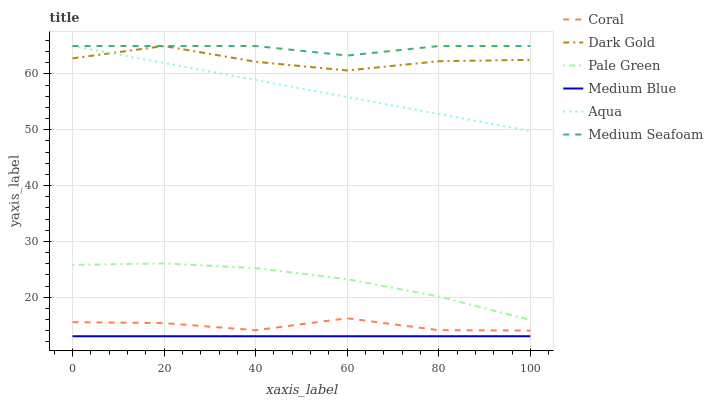Does Medium Blue have the minimum area under the curve?
Answer yes or no. Yes. Does Medium Seafoam have the maximum area under the curve?
Answer yes or no. Yes. Does Coral have the minimum area under the curve?
Answer yes or no. No. Does Coral have the maximum area under the curve?
Answer yes or no. No. Is Aqua the smoothest?
Answer yes or no. Yes. Is Dark Gold the roughest?
Answer yes or no. Yes. Is Medium Blue the smoothest?
Answer yes or no. No. Is Medium Blue the roughest?
Answer yes or no. No. Does Medium Blue have the lowest value?
Answer yes or no. Yes. Does Coral have the lowest value?
Answer yes or no. No. Does Medium Seafoam have the highest value?
Answer yes or no. Yes. Does Coral have the highest value?
Answer yes or no. No. Is Coral less than Aqua?
Answer yes or no. Yes. Is Dark Gold greater than Coral?
Answer yes or no. Yes. Does Dark Gold intersect Medium Seafoam?
Answer yes or no. Yes. Is Dark Gold less than Medium Seafoam?
Answer yes or no. No. Is Dark Gold greater than Medium Seafoam?
Answer yes or no. No. Does Coral intersect Aqua?
Answer yes or no. No. 